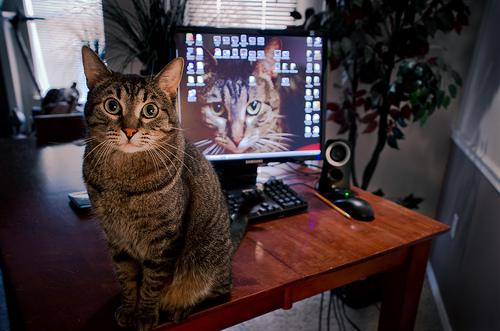Question: what type of computer is shown?
Choices:
A. A mac.
B. A dell.
C. An ipad.
D. A desktop.
Answer with the letter. Answer: D Question: what animal is in the picture?
Choices:
A. A racoon.
B. A cat.
C. An alligator.
D. A fish.
Answer with the letter. Answer: B Question: how is the cat sitting?
Choices:
A. On a pillow.
B. Upright.
C. On a box.
D. On the couch.
Answer with the letter. Answer: B Question: what picture is on the computer screen?
Choices:
A. A garden scene.
B. A cat picture.
C. A sunset scene.
D. Sand.
Answer with the letter. Answer: B 